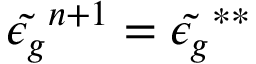Convert formula to latex. <formula><loc_0><loc_0><loc_500><loc_500>\tilde { \epsilon _ { g } } ^ { n + 1 } = \tilde { \epsilon _ { g } } ^ { * * }</formula> 